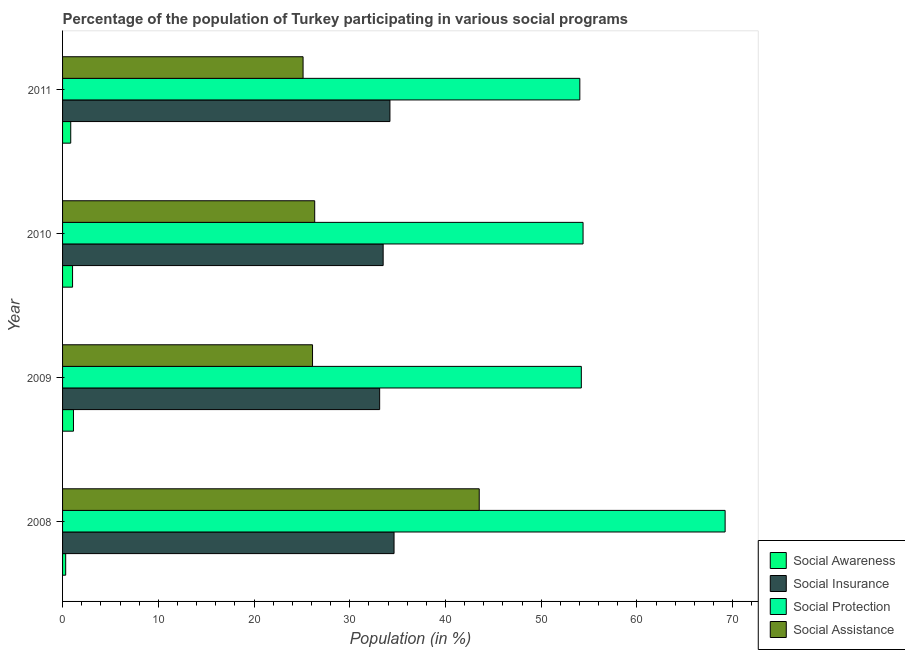Are the number of bars on each tick of the Y-axis equal?
Your answer should be very brief. Yes. How many bars are there on the 4th tick from the top?
Your response must be concise. 4. How many bars are there on the 3rd tick from the bottom?
Offer a terse response. 4. In how many cases, is the number of bars for a given year not equal to the number of legend labels?
Provide a short and direct response. 0. What is the participation of population in social protection programs in 2011?
Keep it short and to the point. 54.03. Across all years, what is the maximum participation of population in social assistance programs?
Offer a terse response. 43.52. Across all years, what is the minimum participation of population in social insurance programs?
Offer a very short reply. 33.12. What is the total participation of population in social awareness programs in the graph?
Make the answer very short. 3.36. What is the difference between the participation of population in social insurance programs in 2008 and the participation of population in social awareness programs in 2011?
Offer a very short reply. 33.77. What is the average participation of population in social assistance programs per year?
Offer a terse response. 30.27. In the year 2008, what is the difference between the participation of population in social protection programs and participation of population in social awareness programs?
Provide a short and direct response. 68.88. Is the participation of population in social assistance programs in 2010 less than that in 2011?
Your answer should be compact. No. Is the difference between the participation of population in social protection programs in 2010 and 2011 greater than the difference between the participation of population in social insurance programs in 2010 and 2011?
Offer a very short reply. Yes. What is the difference between the highest and the second highest participation of population in social insurance programs?
Provide a short and direct response. 0.43. Is the sum of the participation of population in social assistance programs in 2009 and 2011 greater than the maximum participation of population in social awareness programs across all years?
Ensure brevity in your answer.  Yes. Is it the case that in every year, the sum of the participation of population in social awareness programs and participation of population in social protection programs is greater than the sum of participation of population in social assistance programs and participation of population in social insurance programs?
Give a very brief answer. No. What does the 4th bar from the top in 2010 represents?
Offer a very short reply. Social Awareness. What does the 2nd bar from the bottom in 2010 represents?
Your answer should be very brief. Social Insurance. Is it the case that in every year, the sum of the participation of population in social awareness programs and participation of population in social insurance programs is greater than the participation of population in social protection programs?
Offer a very short reply. No. How many bars are there?
Give a very brief answer. 16. Are all the bars in the graph horizontal?
Offer a terse response. Yes. Where does the legend appear in the graph?
Provide a short and direct response. Bottom right. How many legend labels are there?
Keep it short and to the point. 4. What is the title of the graph?
Your answer should be very brief. Percentage of the population of Turkey participating in various social programs . What is the Population (in %) of Social Awareness in 2008?
Ensure brevity in your answer.  0.33. What is the Population (in %) in Social Insurance in 2008?
Provide a succinct answer. 34.62. What is the Population (in %) of Social Protection in 2008?
Make the answer very short. 69.21. What is the Population (in %) in Social Assistance in 2008?
Make the answer very short. 43.52. What is the Population (in %) of Social Awareness in 2009?
Your answer should be very brief. 1.14. What is the Population (in %) in Social Insurance in 2009?
Keep it short and to the point. 33.12. What is the Population (in %) in Social Protection in 2009?
Provide a succinct answer. 54.19. What is the Population (in %) of Social Assistance in 2009?
Offer a terse response. 26.11. What is the Population (in %) of Social Awareness in 2010?
Ensure brevity in your answer.  1.04. What is the Population (in %) in Social Insurance in 2010?
Your response must be concise. 33.49. What is the Population (in %) in Social Protection in 2010?
Ensure brevity in your answer.  54.37. What is the Population (in %) of Social Assistance in 2010?
Provide a short and direct response. 26.34. What is the Population (in %) in Social Awareness in 2011?
Keep it short and to the point. 0.85. What is the Population (in %) of Social Insurance in 2011?
Give a very brief answer. 34.2. What is the Population (in %) of Social Protection in 2011?
Offer a very short reply. 54.03. What is the Population (in %) in Social Assistance in 2011?
Your response must be concise. 25.12. Across all years, what is the maximum Population (in %) in Social Awareness?
Give a very brief answer. 1.14. Across all years, what is the maximum Population (in %) of Social Insurance?
Provide a short and direct response. 34.62. Across all years, what is the maximum Population (in %) of Social Protection?
Your answer should be compact. 69.21. Across all years, what is the maximum Population (in %) in Social Assistance?
Offer a terse response. 43.52. Across all years, what is the minimum Population (in %) of Social Awareness?
Your response must be concise. 0.33. Across all years, what is the minimum Population (in %) in Social Insurance?
Your response must be concise. 33.12. Across all years, what is the minimum Population (in %) of Social Protection?
Ensure brevity in your answer.  54.03. Across all years, what is the minimum Population (in %) of Social Assistance?
Make the answer very short. 25.12. What is the total Population (in %) of Social Awareness in the graph?
Your answer should be very brief. 3.36. What is the total Population (in %) of Social Insurance in the graph?
Provide a short and direct response. 135.43. What is the total Population (in %) of Social Protection in the graph?
Provide a short and direct response. 231.79. What is the total Population (in %) in Social Assistance in the graph?
Provide a succinct answer. 121.09. What is the difference between the Population (in %) of Social Awareness in 2008 and that in 2009?
Offer a terse response. -0.81. What is the difference between the Population (in %) of Social Insurance in 2008 and that in 2009?
Keep it short and to the point. 1.5. What is the difference between the Population (in %) of Social Protection in 2008 and that in 2009?
Your response must be concise. 15.02. What is the difference between the Population (in %) of Social Assistance in 2008 and that in 2009?
Keep it short and to the point. 17.41. What is the difference between the Population (in %) in Social Awareness in 2008 and that in 2010?
Provide a succinct answer. -0.72. What is the difference between the Population (in %) in Social Insurance in 2008 and that in 2010?
Keep it short and to the point. 1.14. What is the difference between the Population (in %) of Social Protection in 2008 and that in 2010?
Ensure brevity in your answer.  14.84. What is the difference between the Population (in %) of Social Assistance in 2008 and that in 2010?
Keep it short and to the point. 17.19. What is the difference between the Population (in %) of Social Awareness in 2008 and that in 2011?
Give a very brief answer. -0.53. What is the difference between the Population (in %) in Social Insurance in 2008 and that in 2011?
Offer a very short reply. 0.43. What is the difference between the Population (in %) in Social Protection in 2008 and that in 2011?
Offer a very short reply. 15.18. What is the difference between the Population (in %) in Social Assistance in 2008 and that in 2011?
Ensure brevity in your answer.  18.4. What is the difference between the Population (in %) of Social Awareness in 2009 and that in 2010?
Provide a succinct answer. 0.09. What is the difference between the Population (in %) in Social Insurance in 2009 and that in 2010?
Give a very brief answer. -0.37. What is the difference between the Population (in %) of Social Protection in 2009 and that in 2010?
Provide a short and direct response. -0.18. What is the difference between the Population (in %) of Social Assistance in 2009 and that in 2010?
Offer a terse response. -0.23. What is the difference between the Population (in %) of Social Awareness in 2009 and that in 2011?
Make the answer very short. 0.29. What is the difference between the Population (in %) in Social Insurance in 2009 and that in 2011?
Provide a short and direct response. -1.07. What is the difference between the Population (in %) in Social Protection in 2009 and that in 2011?
Make the answer very short. 0.16. What is the difference between the Population (in %) of Social Assistance in 2009 and that in 2011?
Provide a short and direct response. 0.99. What is the difference between the Population (in %) of Social Awareness in 2010 and that in 2011?
Provide a succinct answer. 0.19. What is the difference between the Population (in %) in Social Insurance in 2010 and that in 2011?
Give a very brief answer. -0.71. What is the difference between the Population (in %) of Social Protection in 2010 and that in 2011?
Make the answer very short. 0.34. What is the difference between the Population (in %) of Social Assistance in 2010 and that in 2011?
Your answer should be very brief. 1.21. What is the difference between the Population (in %) in Social Awareness in 2008 and the Population (in %) in Social Insurance in 2009?
Your response must be concise. -32.79. What is the difference between the Population (in %) in Social Awareness in 2008 and the Population (in %) in Social Protection in 2009?
Keep it short and to the point. -53.86. What is the difference between the Population (in %) of Social Awareness in 2008 and the Population (in %) of Social Assistance in 2009?
Your answer should be compact. -25.78. What is the difference between the Population (in %) of Social Insurance in 2008 and the Population (in %) of Social Protection in 2009?
Make the answer very short. -19.56. What is the difference between the Population (in %) of Social Insurance in 2008 and the Population (in %) of Social Assistance in 2009?
Give a very brief answer. 8.51. What is the difference between the Population (in %) in Social Protection in 2008 and the Population (in %) in Social Assistance in 2009?
Keep it short and to the point. 43.1. What is the difference between the Population (in %) of Social Awareness in 2008 and the Population (in %) of Social Insurance in 2010?
Your answer should be very brief. -33.16. What is the difference between the Population (in %) in Social Awareness in 2008 and the Population (in %) in Social Protection in 2010?
Make the answer very short. -54.04. What is the difference between the Population (in %) of Social Awareness in 2008 and the Population (in %) of Social Assistance in 2010?
Your answer should be very brief. -26.01. What is the difference between the Population (in %) in Social Insurance in 2008 and the Population (in %) in Social Protection in 2010?
Give a very brief answer. -19.74. What is the difference between the Population (in %) in Social Insurance in 2008 and the Population (in %) in Social Assistance in 2010?
Ensure brevity in your answer.  8.29. What is the difference between the Population (in %) in Social Protection in 2008 and the Population (in %) in Social Assistance in 2010?
Offer a very short reply. 42.87. What is the difference between the Population (in %) of Social Awareness in 2008 and the Population (in %) of Social Insurance in 2011?
Your answer should be compact. -33.87. What is the difference between the Population (in %) of Social Awareness in 2008 and the Population (in %) of Social Protection in 2011?
Make the answer very short. -53.7. What is the difference between the Population (in %) of Social Awareness in 2008 and the Population (in %) of Social Assistance in 2011?
Your response must be concise. -24.8. What is the difference between the Population (in %) in Social Insurance in 2008 and the Population (in %) in Social Protection in 2011?
Offer a terse response. -19.41. What is the difference between the Population (in %) in Social Insurance in 2008 and the Population (in %) in Social Assistance in 2011?
Offer a terse response. 9.5. What is the difference between the Population (in %) of Social Protection in 2008 and the Population (in %) of Social Assistance in 2011?
Your answer should be very brief. 44.09. What is the difference between the Population (in %) in Social Awareness in 2009 and the Population (in %) in Social Insurance in 2010?
Offer a very short reply. -32.35. What is the difference between the Population (in %) of Social Awareness in 2009 and the Population (in %) of Social Protection in 2010?
Provide a short and direct response. -53.23. What is the difference between the Population (in %) in Social Awareness in 2009 and the Population (in %) in Social Assistance in 2010?
Give a very brief answer. -25.2. What is the difference between the Population (in %) of Social Insurance in 2009 and the Population (in %) of Social Protection in 2010?
Make the answer very short. -21.25. What is the difference between the Population (in %) in Social Insurance in 2009 and the Population (in %) in Social Assistance in 2010?
Keep it short and to the point. 6.78. What is the difference between the Population (in %) in Social Protection in 2009 and the Population (in %) in Social Assistance in 2010?
Your answer should be very brief. 27.85. What is the difference between the Population (in %) in Social Awareness in 2009 and the Population (in %) in Social Insurance in 2011?
Ensure brevity in your answer.  -33.06. What is the difference between the Population (in %) of Social Awareness in 2009 and the Population (in %) of Social Protection in 2011?
Your response must be concise. -52.89. What is the difference between the Population (in %) of Social Awareness in 2009 and the Population (in %) of Social Assistance in 2011?
Provide a short and direct response. -23.98. What is the difference between the Population (in %) of Social Insurance in 2009 and the Population (in %) of Social Protection in 2011?
Make the answer very short. -20.91. What is the difference between the Population (in %) of Social Insurance in 2009 and the Population (in %) of Social Assistance in 2011?
Ensure brevity in your answer.  8. What is the difference between the Population (in %) in Social Protection in 2009 and the Population (in %) in Social Assistance in 2011?
Ensure brevity in your answer.  29.06. What is the difference between the Population (in %) of Social Awareness in 2010 and the Population (in %) of Social Insurance in 2011?
Keep it short and to the point. -33.15. What is the difference between the Population (in %) of Social Awareness in 2010 and the Population (in %) of Social Protection in 2011?
Make the answer very short. -52.99. What is the difference between the Population (in %) of Social Awareness in 2010 and the Population (in %) of Social Assistance in 2011?
Your response must be concise. -24.08. What is the difference between the Population (in %) of Social Insurance in 2010 and the Population (in %) of Social Protection in 2011?
Provide a succinct answer. -20.54. What is the difference between the Population (in %) in Social Insurance in 2010 and the Population (in %) in Social Assistance in 2011?
Your answer should be very brief. 8.37. What is the difference between the Population (in %) of Social Protection in 2010 and the Population (in %) of Social Assistance in 2011?
Your answer should be very brief. 29.25. What is the average Population (in %) in Social Awareness per year?
Keep it short and to the point. 0.84. What is the average Population (in %) in Social Insurance per year?
Keep it short and to the point. 33.86. What is the average Population (in %) of Social Protection per year?
Provide a succinct answer. 57.95. What is the average Population (in %) of Social Assistance per year?
Provide a succinct answer. 30.27. In the year 2008, what is the difference between the Population (in %) of Social Awareness and Population (in %) of Social Insurance?
Provide a succinct answer. -34.3. In the year 2008, what is the difference between the Population (in %) in Social Awareness and Population (in %) in Social Protection?
Your answer should be compact. -68.88. In the year 2008, what is the difference between the Population (in %) of Social Awareness and Population (in %) of Social Assistance?
Offer a terse response. -43.2. In the year 2008, what is the difference between the Population (in %) of Social Insurance and Population (in %) of Social Protection?
Your answer should be compact. -34.58. In the year 2008, what is the difference between the Population (in %) in Social Insurance and Population (in %) in Social Assistance?
Offer a terse response. -8.9. In the year 2008, what is the difference between the Population (in %) in Social Protection and Population (in %) in Social Assistance?
Ensure brevity in your answer.  25.68. In the year 2009, what is the difference between the Population (in %) of Social Awareness and Population (in %) of Social Insurance?
Give a very brief answer. -31.98. In the year 2009, what is the difference between the Population (in %) of Social Awareness and Population (in %) of Social Protection?
Your answer should be compact. -53.05. In the year 2009, what is the difference between the Population (in %) in Social Awareness and Population (in %) in Social Assistance?
Your answer should be compact. -24.97. In the year 2009, what is the difference between the Population (in %) of Social Insurance and Population (in %) of Social Protection?
Provide a succinct answer. -21.07. In the year 2009, what is the difference between the Population (in %) in Social Insurance and Population (in %) in Social Assistance?
Offer a terse response. 7.01. In the year 2009, what is the difference between the Population (in %) of Social Protection and Population (in %) of Social Assistance?
Your answer should be very brief. 28.08. In the year 2010, what is the difference between the Population (in %) of Social Awareness and Population (in %) of Social Insurance?
Ensure brevity in your answer.  -32.44. In the year 2010, what is the difference between the Population (in %) in Social Awareness and Population (in %) in Social Protection?
Offer a terse response. -53.32. In the year 2010, what is the difference between the Population (in %) of Social Awareness and Population (in %) of Social Assistance?
Provide a succinct answer. -25.29. In the year 2010, what is the difference between the Population (in %) of Social Insurance and Population (in %) of Social Protection?
Keep it short and to the point. -20.88. In the year 2010, what is the difference between the Population (in %) in Social Insurance and Population (in %) in Social Assistance?
Make the answer very short. 7.15. In the year 2010, what is the difference between the Population (in %) in Social Protection and Population (in %) in Social Assistance?
Your response must be concise. 28.03. In the year 2011, what is the difference between the Population (in %) in Social Awareness and Population (in %) in Social Insurance?
Your answer should be very brief. -33.34. In the year 2011, what is the difference between the Population (in %) in Social Awareness and Population (in %) in Social Protection?
Offer a terse response. -53.18. In the year 2011, what is the difference between the Population (in %) in Social Awareness and Population (in %) in Social Assistance?
Offer a terse response. -24.27. In the year 2011, what is the difference between the Population (in %) in Social Insurance and Population (in %) in Social Protection?
Your answer should be very brief. -19.84. In the year 2011, what is the difference between the Population (in %) of Social Insurance and Population (in %) of Social Assistance?
Your answer should be compact. 9.07. In the year 2011, what is the difference between the Population (in %) in Social Protection and Population (in %) in Social Assistance?
Make the answer very short. 28.91. What is the ratio of the Population (in %) of Social Awareness in 2008 to that in 2009?
Your answer should be compact. 0.29. What is the ratio of the Population (in %) of Social Insurance in 2008 to that in 2009?
Offer a terse response. 1.05. What is the ratio of the Population (in %) of Social Protection in 2008 to that in 2009?
Provide a succinct answer. 1.28. What is the ratio of the Population (in %) in Social Assistance in 2008 to that in 2009?
Offer a very short reply. 1.67. What is the ratio of the Population (in %) in Social Awareness in 2008 to that in 2010?
Your answer should be very brief. 0.31. What is the ratio of the Population (in %) in Social Insurance in 2008 to that in 2010?
Make the answer very short. 1.03. What is the ratio of the Population (in %) in Social Protection in 2008 to that in 2010?
Offer a very short reply. 1.27. What is the ratio of the Population (in %) of Social Assistance in 2008 to that in 2010?
Ensure brevity in your answer.  1.65. What is the ratio of the Population (in %) in Social Awareness in 2008 to that in 2011?
Your answer should be compact. 0.38. What is the ratio of the Population (in %) of Social Insurance in 2008 to that in 2011?
Give a very brief answer. 1.01. What is the ratio of the Population (in %) of Social Protection in 2008 to that in 2011?
Provide a succinct answer. 1.28. What is the ratio of the Population (in %) in Social Assistance in 2008 to that in 2011?
Ensure brevity in your answer.  1.73. What is the ratio of the Population (in %) of Social Awareness in 2009 to that in 2010?
Provide a short and direct response. 1.09. What is the ratio of the Population (in %) in Social Insurance in 2009 to that in 2010?
Your answer should be compact. 0.99. What is the ratio of the Population (in %) of Social Awareness in 2009 to that in 2011?
Offer a very short reply. 1.34. What is the ratio of the Population (in %) in Social Insurance in 2009 to that in 2011?
Provide a succinct answer. 0.97. What is the ratio of the Population (in %) in Social Assistance in 2009 to that in 2011?
Provide a succinct answer. 1.04. What is the ratio of the Population (in %) in Social Awareness in 2010 to that in 2011?
Give a very brief answer. 1.22. What is the ratio of the Population (in %) in Social Insurance in 2010 to that in 2011?
Offer a terse response. 0.98. What is the ratio of the Population (in %) in Social Assistance in 2010 to that in 2011?
Offer a terse response. 1.05. What is the difference between the highest and the second highest Population (in %) in Social Awareness?
Your response must be concise. 0.09. What is the difference between the highest and the second highest Population (in %) in Social Insurance?
Your answer should be very brief. 0.43. What is the difference between the highest and the second highest Population (in %) in Social Protection?
Offer a very short reply. 14.84. What is the difference between the highest and the second highest Population (in %) in Social Assistance?
Make the answer very short. 17.19. What is the difference between the highest and the lowest Population (in %) of Social Awareness?
Your response must be concise. 0.81. What is the difference between the highest and the lowest Population (in %) of Social Insurance?
Provide a succinct answer. 1.5. What is the difference between the highest and the lowest Population (in %) of Social Protection?
Offer a terse response. 15.18. What is the difference between the highest and the lowest Population (in %) in Social Assistance?
Offer a very short reply. 18.4. 